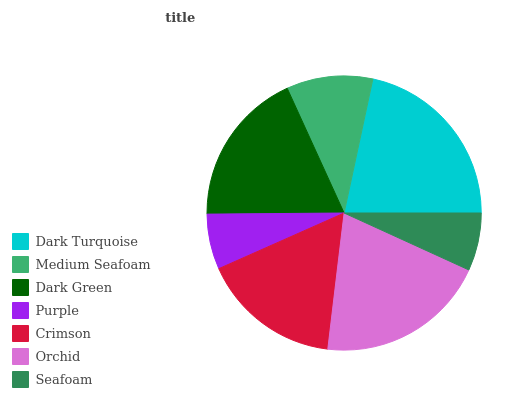Is Purple the minimum?
Answer yes or no. Yes. Is Dark Turquoise the maximum?
Answer yes or no. Yes. Is Medium Seafoam the minimum?
Answer yes or no. No. Is Medium Seafoam the maximum?
Answer yes or no. No. Is Dark Turquoise greater than Medium Seafoam?
Answer yes or no. Yes. Is Medium Seafoam less than Dark Turquoise?
Answer yes or no. Yes. Is Medium Seafoam greater than Dark Turquoise?
Answer yes or no. No. Is Dark Turquoise less than Medium Seafoam?
Answer yes or no. No. Is Crimson the high median?
Answer yes or no. Yes. Is Crimson the low median?
Answer yes or no. Yes. Is Purple the high median?
Answer yes or no. No. Is Purple the low median?
Answer yes or no. No. 